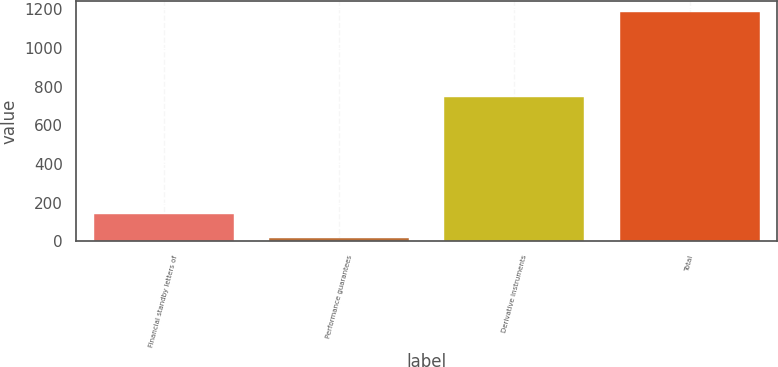<chart> <loc_0><loc_0><loc_500><loc_500><bar_chart><fcel>Financial standby letters of<fcel>Performance guarantees<fcel>Derivative instruments<fcel>Total<nl><fcel>141<fcel>19<fcel>747<fcel>1184<nl></chart> 